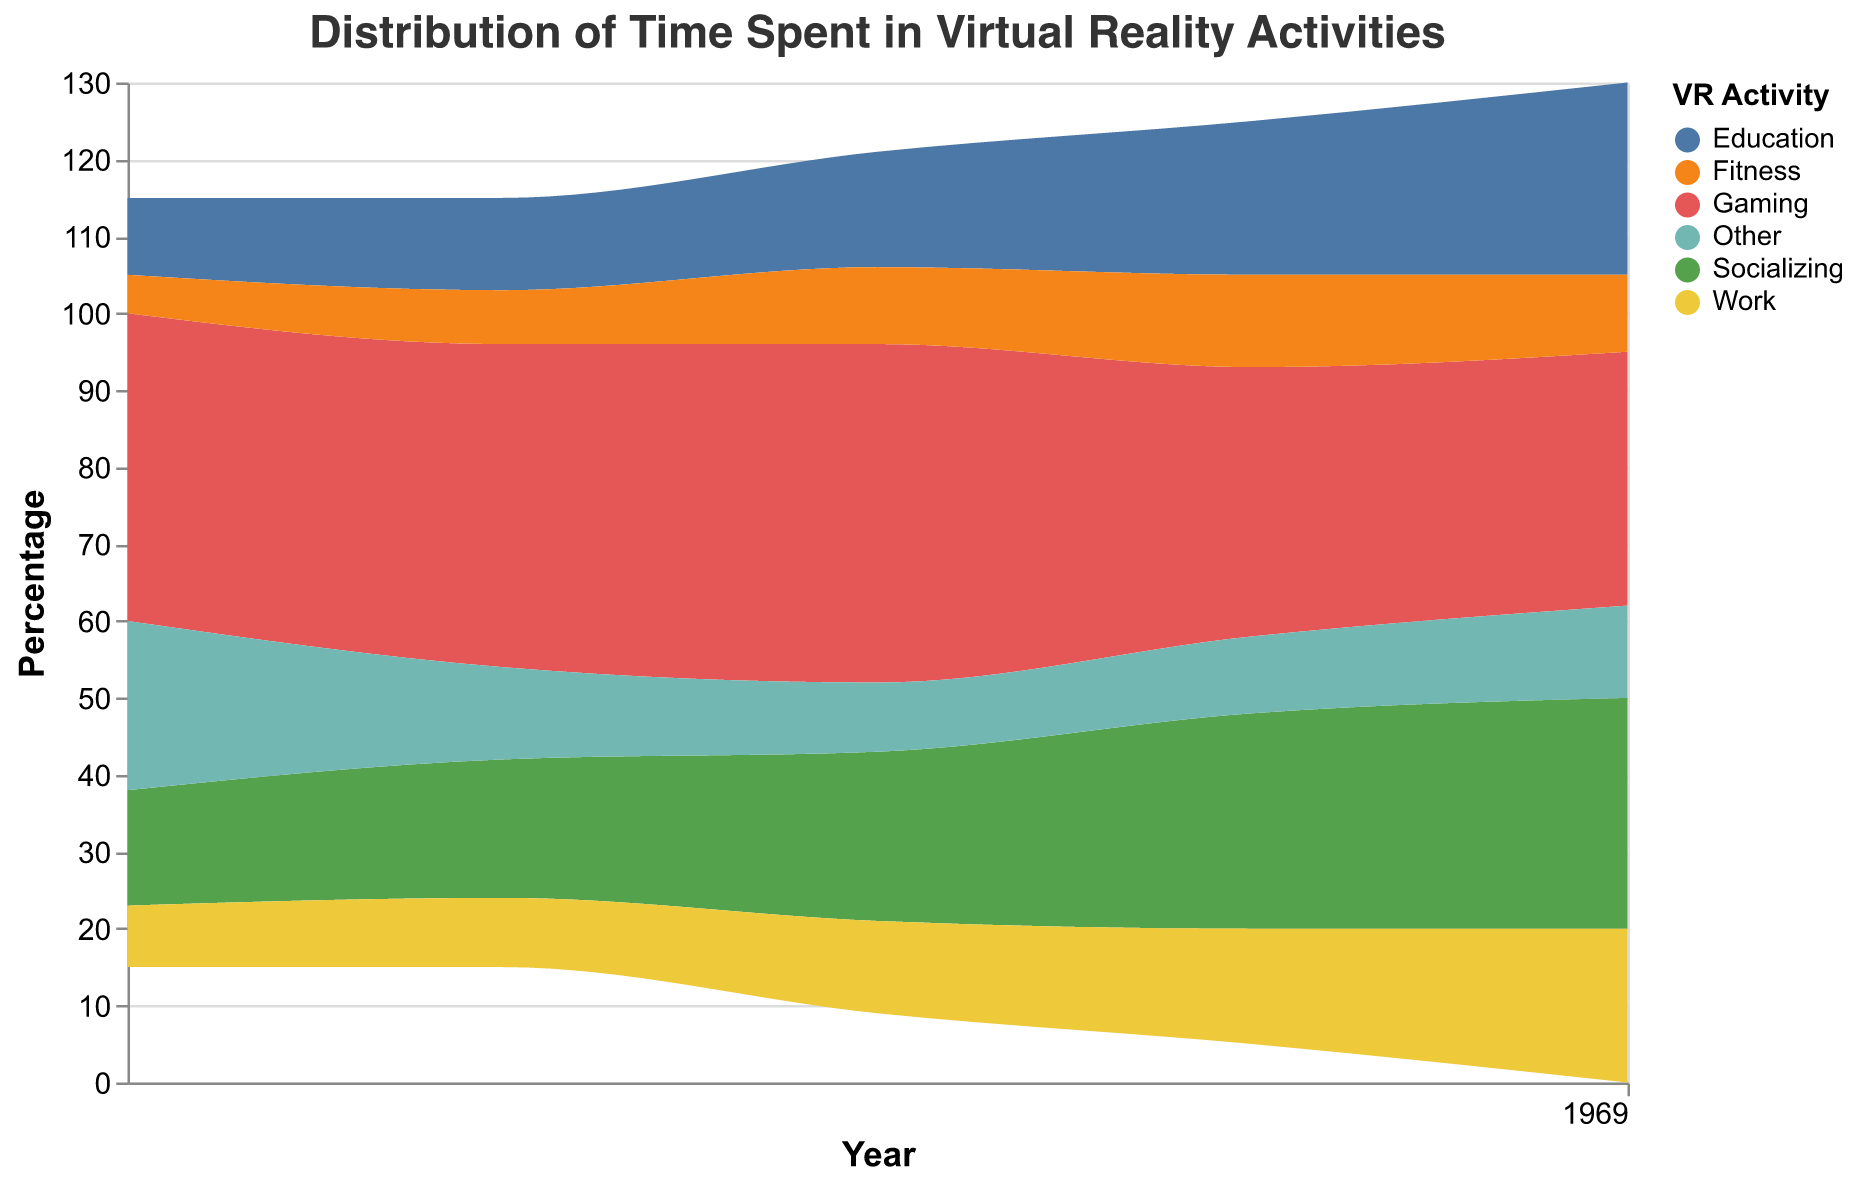What is the title of the chart? The title is shown at the top of the chart.
Answer: Distribution of Time Spent in Virtual Reality Activities What was the percentage of time spent on ‘Work’ in 2020? Locate the ‘Work’ category and check the percentage value for the year 2020.
Answer: 12% In which year did ‘Gaming’ experience the largest decrease in percentage? Compare the year-over-year changes for ‘Gaming’ and find the largest reduction.
Answer: 2020-2021 By how much did the percentage for ‘Education’ increase from 2019 to 2021? Subtract the 2019 value for ‘Education’ from the 2021 value.
Answer: 8% Which activity had the highest overall percentage in 2018? Look at the 2018 data points for all categories and identify the highest value.
Answer: Gaming Which category shows a consistent increasing trend from 2018 to 2022? Review percentage values for each category year over year and identify the one with continuous growth.
Answer: Education Compare the total percentage spent on ‘Socializing’ and ‘Fitness’ in 2022. Which one is higher? Add the 2022 values of both categories and compare them.
Answer: Socializing Which category had a higher percentage in 2019: ‘Gaming’ or ‘Socializing’? Compare the values of 'Gaming' and 'Socializing' for the year 2019.
Answer: Gaming Which activity showed the least volatility over the years? Observe the changes in percentages for each category over the years and identify the one with the smallest changes.
Answer: Fitness How does the percentage for 'Other' in 2018 compare to 2022? Compare the values of 'Other' for the years 2018 and 2022.
Answer: Decreased 